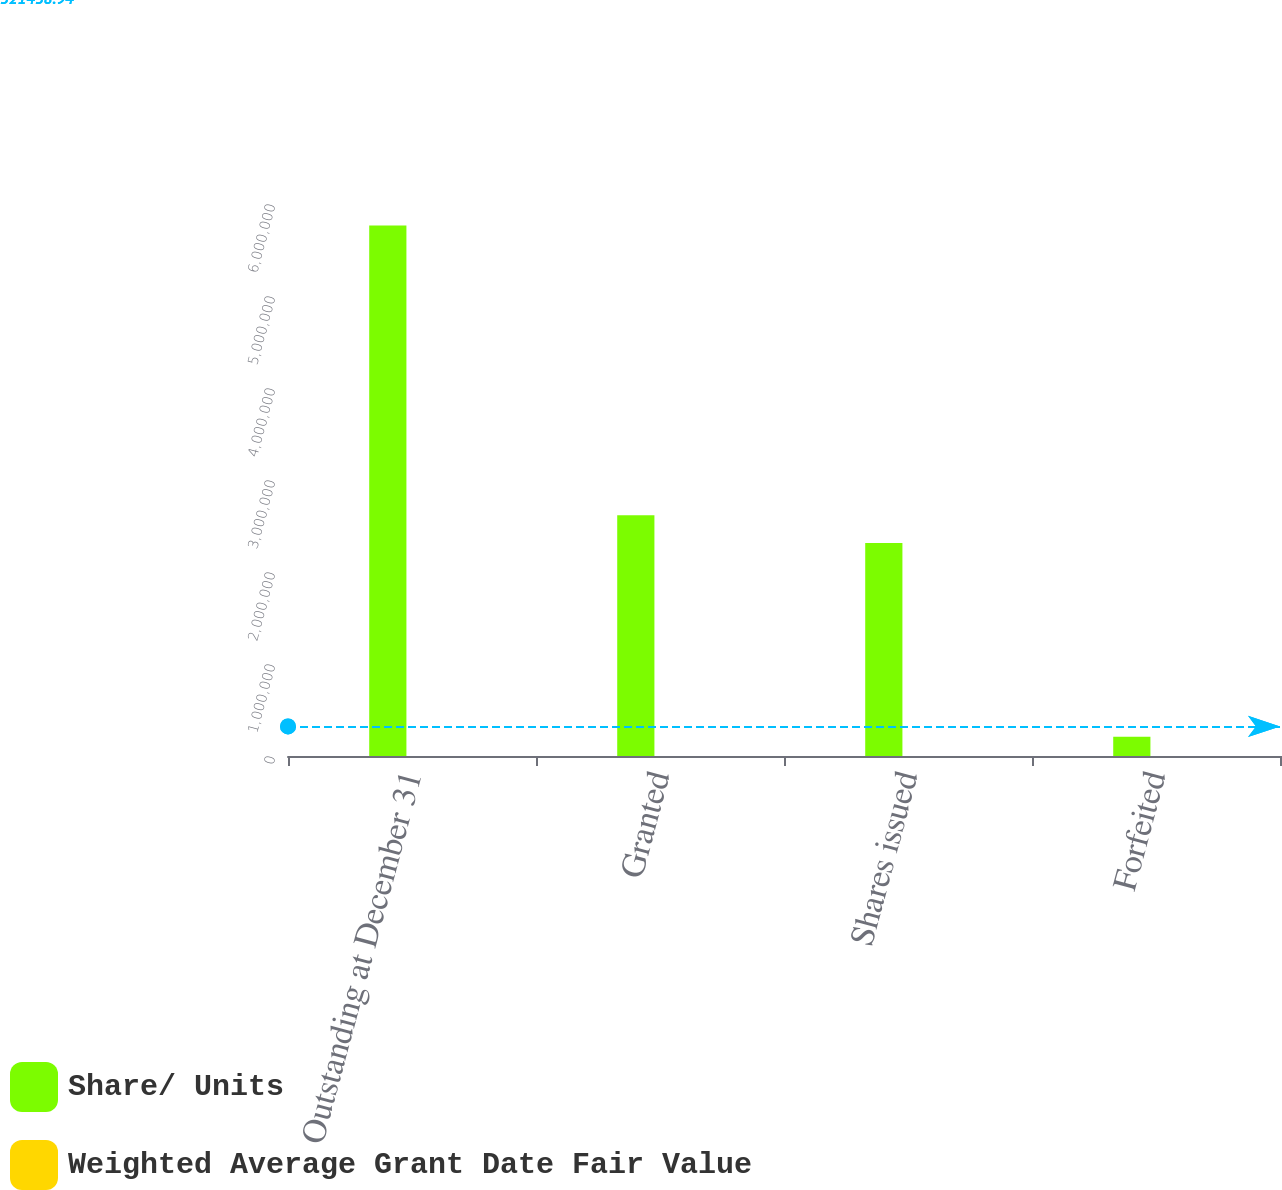<chart> <loc_0><loc_0><loc_500><loc_500><stacked_bar_chart><ecel><fcel>Outstanding at December 31<fcel>Granted<fcel>Shares issued<fcel>Forfeited<nl><fcel>Share/ Units<fcel>5.76648e+06<fcel>2.61798e+06<fcel>2.31608e+06<fcel>209500<nl><fcel>Weighted Average Grant Date Fair Value<fcel>38.79<fcel>37.26<fcel>43.82<fcel>43.61<nl></chart> 